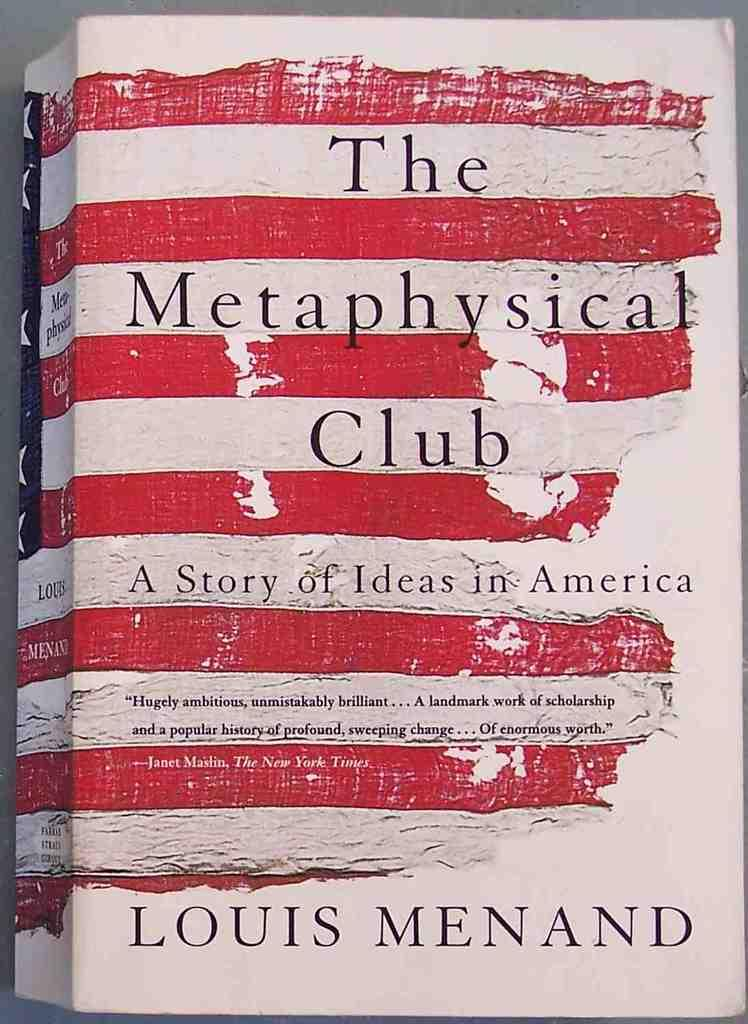<image>
Give a short and clear explanation of the subsequent image. The book "The Metaphysical Club" is about ideas in America. 